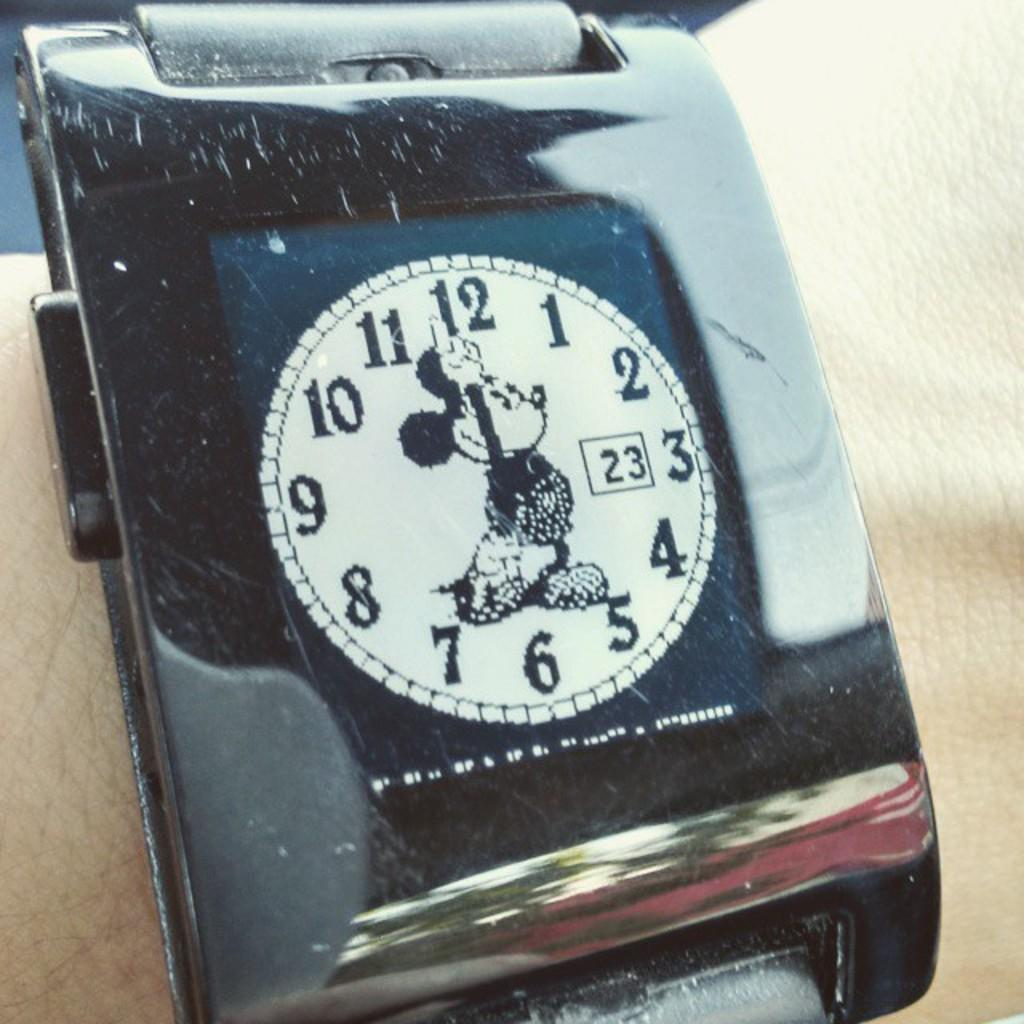<image>
Share a concise interpretation of the image provided. A square watch showing an analog round watch with the 23rd as the date. 